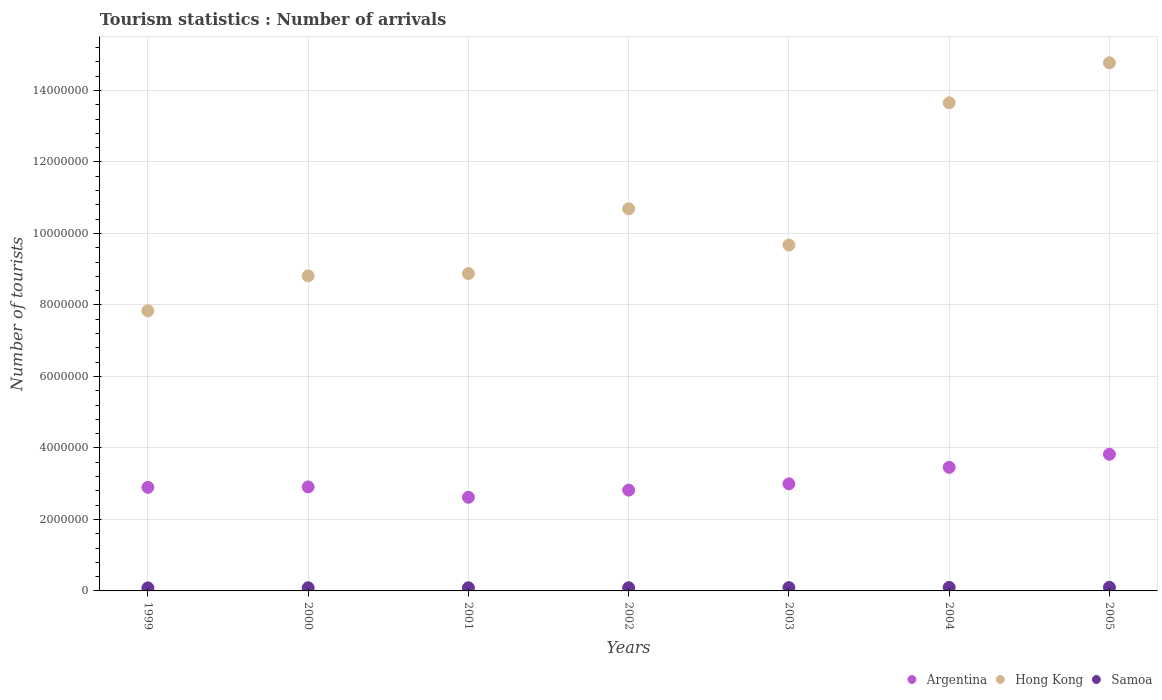How many different coloured dotlines are there?
Make the answer very short. 3. Is the number of dotlines equal to the number of legend labels?
Provide a succinct answer. Yes. What is the number of tourist arrivals in Hong Kong in 2004?
Give a very brief answer. 1.37e+07. Across all years, what is the maximum number of tourist arrivals in Hong Kong?
Offer a very short reply. 1.48e+07. Across all years, what is the minimum number of tourist arrivals in Argentina?
Keep it short and to the point. 2.62e+06. In which year was the number of tourist arrivals in Hong Kong maximum?
Give a very brief answer. 2005. In which year was the number of tourist arrivals in Argentina minimum?
Offer a very short reply. 2001. What is the total number of tourist arrivals in Argentina in the graph?
Give a very brief answer. 2.15e+07. What is the difference between the number of tourist arrivals in Argentina in 2000 and that in 2002?
Ensure brevity in your answer.  8.90e+04. What is the difference between the number of tourist arrivals in Argentina in 2002 and the number of tourist arrivals in Hong Kong in 1999?
Give a very brief answer. -5.02e+06. What is the average number of tourist arrivals in Hong Kong per year?
Your answer should be very brief. 1.06e+07. In the year 2000, what is the difference between the number of tourist arrivals in Hong Kong and number of tourist arrivals in Samoa?
Your answer should be very brief. 8.73e+06. What is the ratio of the number of tourist arrivals in Hong Kong in 2000 to that in 2002?
Make the answer very short. 0.82. Is the number of tourist arrivals in Samoa in 1999 less than that in 2005?
Provide a succinct answer. Yes. What is the difference between the highest and the second highest number of tourist arrivals in Hong Kong?
Provide a succinct answer. 1.12e+06. What is the difference between the highest and the lowest number of tourist arrivals in Hong Kong?
Provide a short and direct response. 6.94e+06. Is the sum of the number of tourist arrivals in Samoa in 2000 and 2002 greater than the maximum number of tourist arrivals in Argentina across all years?
Provide a succinct answer. No. Does the number of tourist arrivals in Hong Kong monotonically increase over the years?
Your answer should be compact. No. Is the number of tourist arrivals in Hong Kong strictly less than the number of tourist arrivals in Argentina over the years?
Your answer should be compact. No. How many dotlines are there?
Provide a short and direct response. 3. How many years are there in the graph?
Give a very brief answer. 7. What is the difference between two consecutive major ticks on the Y-axis?
Offer a terse response. 2.00e+06. What is the title of the graph?
Offer a very short reply. Tourism statistics : Number of arrivals. What is the label or title of the Y-axis?
Your answer should be very brief. Number of tourists. What is the Number of tourists in Argentina in 1999?
Make the answer very short. 2.90e+06. What is the Number of tourists in Hong Kong in 1999?
Provide a short and direct response. 7.84e+06. What is the Number of tourists of Samoa in 1999?
Your answer should be compact. 8.50e+04. What is the Number of tourists in Argentina in 2000?
Offer a terse response. 2.91e+06. What is the Number of tourists of Hong Kong in 2000?
Keep it short and to the point. 8.81e+06. What is the Number of tourists of Samoa in 2000?
Keep it short and to the point. 8.80e+04. What is the Number of tourists in Argentina in 2001?
Keep it short and to the point. 2.62e+06. What is the Number of tourists of Hong Kong in 2001?
Your response must be concise. 8.88e+06. What is the Number of tourists of Samoa in 2001?
Make the answer very short. 8.80e+04. What is the Number of tourists of Argentina in 2002?
Offer a very short reply. 2.82e+06. What is the Number of tourists in Hong Kong in 2002?
Offer a terse response. 1.07e+07. What is the Number of tourists of Samoa in 2002?
Make the answer very short. 8.90e+04. What is the Number of tourists of Argentina in 2003?
Ensure brevity in your answer.  3.00e+06. What is the Number of tourists in Hong Kong in 2003?
Ensure brevity in your answer.  9.68e+06. What is the Number of tourists in Samoa in 2003?
Ensure brevity in your answer.  9.20e+04. What is the Number of tourists of Argentina in 2004?
Offer a terse response. 3.46e+06. What is the Number of tourists of Hong Kong in 2004?
Your answer should be very brief. 1.37e+07. What is the Number of tourists in Samoa in 2004?
Provide a short and direct response. 9.80e+04. What is the Number of tourists of Argentina in 2005?
Your answer should be compact. 3.82e+06. What is the Number of tourists in Hong Kong in 2005?
Ensure brevity in your answer.  1.48e+07. What is the Number of tourists of Samoa in 2005?
Ensure brevity in your answer.  1.02e+05. Across all years, what is the maximum Number of tourists in Argentina?
Provide a short and direct response. 3.82e+06. Across all years, what is the maximum Number of tourists of Hong Kong?
Keep it short and to the point. 1.48e+07. Across all years, what is the maximum Number of tourists of Samoa?
Offer a very short reply. 1.02e+05. Across all years, what is the minimum Number of tourists in Argentina?
Your response must be concise. 2.62e+06. Across all years, what is the minimum Number of tourists of Hong Kong?
Ensure brevity in your answer.  7.84e+06. Across all years, what is the minimum Number of tourists in Samoa?
Offer a terse response. 8.50e+04. What is the total Number of tourists in Argentina in the graph?
Provide a short and direct response. 2.15e+07. What is the total Number of tourists in Hong Kong in the graph?
Your answer should be very brief. 7.43e+07. What is the total Number of tourists of Samoa in the graph?
Offer a terse response. 6.42e+05. What is the difference between the Number of tourists of Argentina in 1999 and that in 2000?
Ensure brevity in your answer.  -1.10e+04. What is the difference between the Number of tourists of Hong Kong in 1999 and that in 2000?
Keep it short and to the point. -9.77e+05. What is the difference between the Number of tourists of Samoa in 1999 and that in 2000?
Offer a terse response. -3000. What is the difference between the Number of tourists of Argentina in 1999 and that in 2001?
Ensure brevity in your answer.  2.78e+05. What is the difference between the Number of tourists of Hong Kong in 1999 and that in 2001?
Give a very brief answer. -1.04e+06. What is the difference between the Number of tourists of Samoa in 1999 and that in 2001?
Ensure brevity in your answer.  -3000. What is the difference between the Number of tourists in Argentina in 1999 and that in 2002?
Make the answer very short. 7.80e+04. What is the difference between the Number of tourists of Hong Kong in 1999 and that in 2002?
Provide a short and direct response. -2.85e+06. What is the difference between the Number of tourists of Samoa in 1999 and that in 2002?
Offer a very short reply. -4000. What is the difference between the Number of tourists of Argentina in 1999 and that in 2003?
Your answer should be compact. -9.70e+04. What is the difference between the Number of tourists of Hong Kong in 1999 and that in 2003?
Your answer should be compact. -1.84e+06. What is the difference between the Number of tourists of Samoa in 1999 and that in 2003?
Make the answer very short. -7000. What is the difference between the Number of tourists of Argentina in 1999 and that in 2004?
Keep it short and to the point. -5.59e+05. What is the difference between the Number of tourists of Hong Kong in 1999 and that in 2004?
Provide a short and direct response. -5.82e+06. What is the difference between the Number of tourists of Samoa in 1999 and that in 2004?
Offer a very short reply. -1.30e+04. What is the difference between the Number of tourists in Argentina in 1999 and that in 2005?
Make the answer very short. -9.25e+05. What is the difference between the Number of tourists of Hong Kong in 1999 and that in 2005?
Keep it short and to the point. -6.94e+06. What is the difference between the Number of tourists of Samoa in 1999 and that in 2005?
Provide a succinct answer. -1.70e+04. What is the difference between the Number of tourists in Argentina in 2000 and that in 2001?
Ensure brevity in your answer.  2.89e+05. What is the difference between the Number of tourists in Hong Kong in 2000 and that in 2001?
Your response must be concise. -6.40e+04. What is the difference between the Number of tourists in Argentina in 2000 and that in 2002?
Your response must be concise. 8.90e+04. What is the difference between the Number of tourists in Hong Kong in 2000 and that in 2002?
Keep it short and to the point. -1.88e+06. What is the difference between the Number of tourists of Samoa in 2000 and that in 2002?
Offer a very short reply. -1000. What is the difference between the Number of tourists of Argentina in 2000 and that in 2003?
Your answer should be compact. -8.60e+04. What is the difference between the Number of tourists in Hong Kong in 2000 and that in 2003?
Provide a short and direct response. -8.62e+05. What is the difference between the Number of tourists of Samoa in 2000 and that in 2003?
Keep it short and to the point. -4000. What is the difference between the Number of tourists of Argentina in 2000 and that in 2004?
Your response must be concise. -5.48e+05. What is the difference between the Number of tourists of Hong Kong in 2000 and that in 2004?
Keep it short and to the point. -4.84e+06. What is the difference between the Number of tourists of Samoa in 2000 and that in 2004?
Offer a terse response. -10000. What is the difference between the Number of tourists of Argentina in 2000 and that in 2005?
Your answer should be compact. -9.14e+05. What is the difference between the Number of tourists in Hong Kong in 2000 and that in 2005?
Give a very brief answer. -5.96e+06. What is the difference between the Number of tourists in Samoa in 2000 and that in 2005?
Give a very brief answer. -1.40e+04. What is the difference between the Number of tourists of Hong Kong in 2001 and that in 2002?
Offer a very short reply. -1.81e+06. What is the difference between the Number of tourists of Samoa in 2001 and that in 2002?
Give a very brief answer. -1000. What is the difference between the Number of tourists in Argentina in 2001 and that in 2003?
Provide a succinct answer. -3.75e+05. What is the difference between the Number of tourists in Hong Kong in 2001 and that in 2003?
Give a very brief answer. -7.98e+05. What is the difference between the Number of tourists in Samoa in 2001 and that in 2003?
Keep it short and to the point. -4000. What is the difference between the Number of tourists in Argentina in 2001 and that in 2004?
Your answer should be compact. -8.37e+05. What is the difference between the Number of tourists in Hong Kong in 2001 and that in 2004?
Provide a short and direct response. -4.78e+06. What is the difference between the Number of tourists in Argentina in 2001 and that in 2005?
Offer a terse response. -1.20e+06. What is the difference between the Number of tourists of Hong Kong in 2001 and that in 2005?
Give a very brief answer. -5.90e+06. What is the difference between the Number of tourists in Samoa in 2001 and that in 2005?
Provide a succinct answer. -1.40e+04. What is the difference between the Number of tourists in Argentina in 2002 and that in 2003?
Your answer should be very brief. -1.75e+05. What is the difference between the Number of tourists in Hong Kong in 2002 and that in 2003?
Your response must be concise. 1.01e+06. What is the difference between the Number of tourists in Samoa in 2002 and that in 2003?
Your response must be concise. -3000. What is the difference between the Number of tourists of Argentina in 2002 and that in 2004?
Provide a succinct answer. -6.37e+05. What is the difference between the Number of tourists of Hong Kong in 2002 and that in 2004?
Offer a terse response. -2.97e+06. What is the difference between the Number of tourists of Samoa in 2002 and that in 2004?
Give a very brief answer. -9000. What is the difference between the Number of tourists of Argentina in 2002 and that in 2005?
Ensure brevity in your answer.  -1.00e+06. What is the difference between the Number of tourists in Hong Kong in 2002 and that in 2005?
Provide a succinct answer. -4.08e+06. What is the difference between the Number of tourists of Samoa in 2002 and that in 2005?
Give a very brief answer. -1.30e+04. What is the difference between the Number of tourists in Argentina in 2003 and that in 2004?
Your answer should be compact. -4.62e+05. What is the difference between the Number of tourists in Hong Kong in 2003 and that in 2004?
Make the answer very short. -3.98e+06. What is the difference between the Number of tourists in Samoa in 2003 and that in 2004?
Offer a terse response. -6000. What is the difference between the Number of tourists in Argentina in 2003 and that in 2005?
Provide a succinct answer. -8.28e+05. What is the difference between the Number of tourists of Hong Kong in 2003 and that in 2005?
Make the answer very short. -5.10e+06. What is the difference between the Number of tourists in Samoa in 2003 and that in 2005?
Offer a terse response. -10000. What is the difference between the Number of tourists in Argentina in 2004 and that in 2005?
Your answer should be compact. -3.66e+05. What is the difference between the Number of tourists of Hong Kong in 2004 and that in 2005?
Offer a terse response. -1.12e+06. What is the difference between the Number of tourists of Samoa in 2004 and that in 2005?
Keep it short and to the point. -4000. What is the difference between the Number of tourists of Argentina in 1999 and the Number of tourists of Hong Kong in 2000?
Offer a terse response. -5.92e+06. What is the difference between the Number of tourists of Argentina in 1999 and the Number of tourists of Samoa in 2000?
Offer a very short reply. 2.81e+06. What is the difference between the Number of tourists in Hong Kong in 1999 and the Number of tourists in Samoa in 2000?
Give a very brief answer. 7.75e+06. What is the difference between the Number of tourists of Argentina in 1999 and the Number of tourists of Hong Kong in 2001?
Provide a succinct answer. -5.98e+06. What is the difference between the Number of tourists in Argentina in 1999 and the Number of tourists in Samoa in 2001?
Your response must be concise. 2.81e+06. What is the difference between the Number of tourists of Hong Kong in 1999 and the Number of tourists of Samoa in 2001?
Provide a short and direct response. 7.75e+06. What is the difference between the Number of tourists in Argentina in 1999 and the Number of tourists in Hong Kong in 2002?
Provide a short and direct response. -7.79e+06. What is the difference between the Number of tourists of Argentina in 1999 and the Number of tourists of Samoa in 2002?
Make the answer very short. 2.81e+06. What is the difference between the Number of tourists in Hong Kong in 1999 and the Number of tourists in Samoa in 2002?
Ensure brevity in your answer.  7.75e+06. What is the difference between the Number of tourists in Argentina in 1999 and the Number of tourists in Hong Kong in 2003?
Ensure brevity in your answer.  -6.78e+06. What is the difference between the Number of tourists of Argentina in 1999 and the Number of tourists of Samoa in 2003?
Your response must be concise. 2.81e+06. What is the difference between the Number of tourists of Hong Kong in 1999 and the Number of tourists of Samoa in 2003?
Your response must be concise. 7.74e+06. What is the difference between the Number of tourists in Argentina in 1999 and the Number of tourists in Hong Kong in 2004?
Offer a very short reply. -1.08e+07. What is the difference between the Number of tourists of Argentina in 1999 and the Number of tourists of Samoa in 2004?
Offer a very short reply. 2.80e+06. What is the difference between the Number of tourists in Hong Kong in 1999 and the Number of tourists in Samoa in 2004?
Offer a very short reply. 7.74e+06. What is the difference between the Number of tourists of Argentina in 1999 and the Number of tourists of Hong Kong in 2005?
Your response must be concise. -1.19e+07. What is the difference between the Number of tourists of Argentina in 1999 and the Number of tourists of Samoa in 2005?
Provide a short and direct response. 2.80e+06. What is the difference between the Number of tourists of Hong Kong in 1999 and the Number of tourists of Samoa in 2005?
Provide a succinct answer. 7.74e+06. What is the difference between the Number of tourists of Argentina in 2000 and the Number of tourists of Hong Kong in 2001?
Your response must be concise. -5.97e+06. What is the difference between the Number of tourists of Argentina in 2000 and the Number of tourists of Samoa in 2001?
Offer a very short reply. 2.82e+06. What is the difference between the Number of tourists of Hong Kong in 2000 and the Number of tourists of Samoa in 2001?
Offer a terse response. 8.73e+06. What is the difference between the Number of tourists of Argentina in 2000 and the Number of tourists of Hong Kong in 2002?
Give a very brief answer. -7.78e+06. What is the difference between the Number of tourists of Argentina in 2000 and the Number of tourists of Samoa in 2002?
Provide a short and direct response. 2.82e+06. What is the difference between the Number of tourists of Hong Kong in 2000 and the Number of tourists of Samoa in 2002?
Keep it short and to the point. 8.72e+06. What is the difference between the Number of tourists in Argentina in 2000 and the Number of tourists in Hong Kong in 2003?
Offer a terse response. -6.77e+06. What is the difference between the Number of tourists of Argentina in 2000 and the Number of tourists of Samoa in 2003?
Give a very brief answer. 2.82e+06. What is the difference between the Number of tourists of Hong Kong in 2000 and the Number of tourists of Samoa in 2003?
Your answer should be very brief. 8.72e+06. What is the difference between the Number of tourists in Argentina in 2000 and the Number of tourists in Hong Kong in 2004?
Offer a terse response. -1.07e+07. What is the difference between the Number of tourists in Argentina in 2000 and the Number of tourists in Samoa in 2004?
Ensure brevity in your answer.  2.81e+06. What is the difference between the Number of tourists of Hong Kong in 2000 and the Number of tourists of Samoa in 2004?
Provide a short and direct response. 8.72e+06. What is the difference between the Number of tourists of Argentina in 2000 and the Number of tourists of Hong Kong in 2005?
Offer a terse response. -1.19e+07. What is the difference between the Number of tourists of Argentina in 2000 and the Number of tourists of Samoa in 2005?
Provide a succinct answer. 2.81e+06. What is the difference between the Number of tourists in Hong Kong in 2000 and the Number of tourists in Samoa in 2005?
Provide a succinct answer. 8.71e+06. What is the difference between the Number of tourists of Argentina in 2001 and the Number of tourists of Hong Kong in 2002?
Provide a short and direct response. -8.07e+06. What is the difference between the Number of tourists in Argentina in 2001 and the Number of tourists in Samoa in 2002?
Keep it short and to the point. 2.53e+06. What is the difference between the Number of tourists in Hong Kong in 2001 and the Number of tourists in Samoa in 2002?
Your answer should be compact. 8.79e+06. What is the difference between the Number of tourists of Argentina in 2001 and the Number of tourists of Hong Kong in 2003?
Your answer should be compact. -7.06e+06. What is the difference between the Number of tourists of Argentina in 2001 and the Number of tourists of Samoa in 2003?
Ensure brevity in your answer.  2.53e+06. What is the difference between the Number of tourists of Hong Kong in 2001 and the Number of tourists of Samoa in 2003?
Your answer should be compact. 8.79e+06. What is the difference between the Number of tourists of Argentina in 2001 and the Number of tourists of Hong Kong in 2004?
Keep it short and to the point. -1.10e+07. What is the difference between the Number of tourists of Argentina in 2001 and the Number of tourists of Samoa in 2004?
Offer a terse response. 2.52e+06. What is the difference between the Number of tourists in Hong Kong in 2001 and the Number of tourists in Samoa in 2004?
Keep it short and to the point. 8.78e+06. What is the difference between the Number of tourists of Argentina in 2001 and the Number of tourists of Hong Kong in 2005?
Ensure brevity in your answer.  -1.22e+07. What is the difference between the Number of tourists of Argentina in 2001 and the Number of tourists of Samoa in 2005?
Make the answer very short. 2.52e+06. What is the difference between the Number of tourists of Hong Kong in 2001 and the Number of tourists of Samoa in 2005?
Ensure brevity in your answer.  8.78e+06. What is the difference between the Number of tourists of Argentina in 2002 and the Number of tourists of Hong Kong in 2003?
Ensure brevity in your answer.  -6.86e+06. What is the difference between the Number of tourists in Argentina in 2002 and the Number of tourists in Samoa in 2003?
Make the answer very short. 2.73e+06. What is the difference between the Number of tourists in Hong Kong in 2002 and the Number of tourists in Samoa in 2003?
Give a very brief answer. 1.06e+07. What is the difference between the Number of tourists of Argentina in 2002 and the Number of tourists of Hong Kong in 2004?
Your answer should be very brief. -1.08e+07. What is the difference between the Number of tourists in Argentina in 2002 and the Number of tourists in Samoa in 2004?
Offer a terse response. 2.72e+06. What is the difference between the Number of tourists of Hong Kong in 2002 and the Number of tourists of Samoa in 2004?
Provide a succinct answer. 1.06e+07. What is the difference between the Number of tourists of Argentina in 2002 and the Number of tourists of Hong Kong in 2005?
Offer a terse response. -1.20e+07. What is the difference between the Number of tourists of Argentina in 2002 and the Number of tourists of Samoa in 2005?
Provide a short and direct response. 2.72e+06. What is the difference between the Number of tourists in Hong Kong in 2002 and the Number of tourists in Samoa in 2005?
Make the answer very short. 1.06e+07. What is the difference between the Number of tourists of Argentina in 2003 and the Number of tourists of Hong Kong in 2004?
Provide a succinct answer. -1.07e+07. What is the difference between the Number of tourists in Argentina in 2003 and the Number of tourists in Samoa in 2004?
Your response must be concise. 2.90e+06. What is the difference between the Number of tourists of Hong Kong in 2003 and the Number of tourists of Samoa in 2004?
Keep it short and to the point. 9.58e+06. What is the difference between the Number of tourists of Argentina in 2003 and the Number of tourists of Hong Kong in 2005?
Ensure brevity in your answer.  -1.18e+07. What is the difference between the Number of tourists in Argentina in 2003 and the Number of tourists in Samoa in 2005?
Offer a terse response. 2.89e+06. What is the difference between the Number of tourists in Hong Kong in 2003 and the Number of tourists in Samoa in 2005?
Keep it short and to the point. 9.57e+06. What is the difference between the Number of tourists of Argentina in 2004 and the Number of tourists of Hong Kong in 2005?
Keep it short and to the point. -1.13e+07. What is the difference between the Number of tourists in Argentina in 2004 and the Number of tourists in Samoa in 2005?
Offer a terse response. 3.36e+06. What is the difference between the Number of tourists in Hong Kong in 2004 and the Number of tourists in Samoa in 2005?
Give a very brief answer. 1.36e+07. What is the average Number of tourists of Argentina per year?
Ensure brevity in your answer.  3.07e+06. What is the average Number of tourists of Hong Kong per year?
Make the answer very short. 1.06e+07. What is the average Number of tourists of Samoa per year?
Give a very brief answer. 9.17e+04. In the year 1999, what is the difference between the Number of tourists in Argentina and Number of tourists in Hong Kong?
Provide a short and direct response. -4.94e+06. In the year 1999, what is the difference between the Number of tourists in Argentina and Number of tourists in Samoa?
Provide a short and direct response. 2.81e+06. In the year 1999, what is the difference between the Number of tourists in Hong Kong and Number of tourists in Samoa?
Keep it short and to the point. 7.75e+06. In the year 2000, what is the difference between the Number of tourists in Argentina and Number of tourists in Hong Kong?
Make the answer very short. -5.90e+06. In the year 2000, what is the difference between the Number of tourists of Argentina and Number of tourists of Samoa?
Give a very brief answer. 2.82e+06. In the year 2000, what is the difference between the Number of tourists of Hong Kong and Number of tourists of Samoa?
Keep it short and to the point. 8.73e+06. In the year 2001, what is the difference between the Number of tourists in Argentina and Number of tourists in Hong Kong?
Your answer should be compact. -6.26e+06. In the year 2001, what is the difference between the Number of tourists in Argentina and Number of tourists in Samoa?
Offer a very short reply. 2.53e+06. In the year 2001, what is the difference between the Number of tourists in Hong Kong and Number of tourists in Samoa?
Your answer should be very brief. 8.79e+06. In the year 2002, what is the difference between the Number of tourists in Argentina and Number of tourists in Hong Kong?
Make the answer very short. -7.87e+06. In the year 2002, what is the difference between the Number of tourists in Argentina and Number of tourists in Samoa?
Offer a very short reply. 2.73e+06. In the year 2002, what is the difference between the Number of tourists of Hong Kong and Number of tourists of Samoa?
Offer a terse response. 1.06e+07. In the year 2003, what is the difference between the Number of tourists in Argentina and Number of tourists in Hong Kong?
Provide a succinct answer. -6.68e+06. In the year 2003, what is the difference between the Number of tourists in Argentina and Number of tourists in Samoa?
Make the answer very short. 2.90e+06. In the year 2003, what is the difference between the Number of tourists of Hong Kong and Number of tourists of Samoa?
Your response must be concise. 9.58e+06. In the year 2004, what is the difference between the Number of tourists of Argentina and Number of tourists of Hong Kong?
Your answer should be compact. -1.02e+07. In the year 2004, what is the difference between the Number of tourists of Argentina and Number of tourists of Samoa?
Ensure brevity in your answer.  3.36e+06. In the year 2004, what is the difference between the Number of tourists of Hong Kong and Number of tourists of Samoa?
Your response must be concise. 1.36e+07. In the year 2005, what is the difference between the Number of tourists in Argentina and Number of tourists in Hong Kong?
Give a very brief answer. -1.10e+07. In the year 2005, what is the difference between the Number of tourists of Argentina and Number of tourists of Samoa?
Offer a very short reply. 3.72e+06. In the year 2005, what is the difference between the Number of tourists in Hong Kong and Number of tourists in Samoa?
Provide a succinct answer. 1.47e+07. What is the ratio of the Number of tourists in Argentina in 1999 to that in 2000?
Ensure brevity in your answer.  1. What is the ratio of the Number of tourists of Hong Kong in 1999 to that in 2000?
Offer a very short reply. 0.89. What is the ratio of the Number of tourists of Samoa in 1999 to that in 2000?
Ensure brevity in your answer.  0.97. What is the ratio of the Number of tourists of Argentina in 1999 to that in 2001?
Your answer should be compact. 1.11. What is the ratio of the Number of tourists in Hong Kong in 1999 to that in 2001?
Ensure brevity in your answer.  0.88. What is the ratio of the Number of tourists in Samoa in 1999 to that in 2001?
Make the answer very short. 0.97. What is the ratio of the Number of tourists of Argentina in 1999 to that in 2002?
Offer a very short reply. 1.03. What is the ratio of the Number of tourists in Hong Kong in 1999 to that in 2002?
Your answer should be very brief. 0.73. What is the ratio of the Number of tourists of Samoa in 1999 to that in 2002?
Ensure brevity in your answer.  0.96. What is the ratio of the Number of tourists of Argentina in 1999 to that in 2003?
Ensure brevity in your answer.  0.97. What is the ratio of the Number of tourists in Hong Kong in 1999 to that in 2003?
Provide a succinct answer. 0.81. What is the ratio of the Number of tourists of Samoa in 1999 to that in 2003?
Keep it short and to the point. 0.92. What is the ratio of the Number of tourists of Argentina in 1999 to that in 2004?
Give a very brief answer. 0.84. What is the ratio of the Number of tourists in Hong Kong in 1999 to that in 2004?
Keep it short and to the point. 0.57. What is the ratio of the Number of tourists of Samoa in 1999 to that in 2004?
Keep it short and to the point. 0.87. What is the ratio of the Number of tourists of Argentina in 1999 to that in 2005?
Keep it short and to the point. 0.76. What is the ratio of the Number of tourists in Hong Kong in 1999 to that in 2005?
Make the answer very short. 0.53. What is the ratio of the Number of tourists in Samoa in 1999 to that in 2005?
Make the answer very short. 0.83. What is the ratio of the Number of tourists of Argentina in 2000 to that in 2001?
Your response must be concise. 1.11. What is the ratio of the Number of tourists in Samoa in 2000 to that in 2001?
Make the answer very short. 1. What is the ratio of the Number of tourists in Argentina in 2000 to that in 2002?
Your response must be concise. 1.03. What is the ratio of the Number of tourists of Hong Kong in 2000 to that in 2002?
Provide a succinct answer. 0.82. What is the ratio of the Number of tourists in Samoa in 2000 to that in 2002?
Provide a succinct answer. 0.99. What is the ratio of the Number of tourists of Argentina in 2000 to that in 2003?
Ensure brevity in your answer.  0.97. What is the ratio of the Number of tourists of Hong Kong in 2000 to that in 2003?
Provide a succinct answer. 0.91. What is the ratio of the Number of tourists of Samoa in 2000 to that in 2003?
Your response must be concise. 0.96. What is the ratio of the Number of tourists in Argentina in 2000 to that in 2004?
Ensure brevity in your answer.  0.84. What is the ratio of the Number of tourists of Hong Kong in 2000 to that in 2004?
Your response must be concise. 0.65. What is the ratio of the Number of tourists in Samoa in 2000 to that in 2004?
Keep it short and to the point. 0.9. What is the ratio of the Number of tourists of Argentina in 2000 to that in 2005?
Your response must be concise. 0.76. What is the ratio of the Number of tourists in Hong Kong in 2000 to that in 2005?
Give a very brief answer. 0.6. What is the ratio of the Number of tourists of Samoa in 2000 to that in 2005?
Ensure brevity in your answer.  0.86. What is the ratio of the Number of tourists of Argentina in 2001 to that in 2002?
Give a very brief answer. 0.93. What is the ratio of the Number of tourists in Hong Kong in 2001 to that in 2002?
Make the answer very short. 0.83. What is the ratio of the Number of tourists of Samoa in 2001 to that in 2002?
Ensure brevity in your answer.  0.99. What is the ratio of the Number of tourists of Argentina in 2001 to that in 2003?
Ensure brevity in your answer.  0.87. What is the ratio of the Number of tourists in Hong Kong in 2001 to that in 2003?
Provide a short and direct response. 0.92. What is the ratio of the Number of tourists of Samoa in 2001 to that in 2003?
Provide a short and direct response. 0.96. What is the ratio of the Number of tourists of Argentina in 2001 to that in 2004?
Provide a short and direct response. 0.76. What is the ratio of the Number of tourists of Hong Kong in 2001 to that in 2004?
Provide a short and direct response. 0.65. What is the ratio of the Number of tourists in Samoa in 2001 to that in 2004?
Offer a very short reply. 0.9. What is the ratio of the Number of tourists in Argentina in 2001 to that in 2005?
Your answer should be compact. 0.69. What is the ratio of the Number of tourists in Hong Kong in 2001 to that in 2005?
Offer a terse response. 0.6. What is the ratio of the Number of tourists in Samoa in 2001 to that in 2005?
Offer a very short reply. 0.86. What is the ratio of the Number of tourists in Argentina in 2002 to that in 2003?
Provide a short and direct response. 0.94. What is the ratio of the Number of tourists in Hong Kong in 2002 to that in 2003?
Make the answer very short. 1.1. What is the ratio of the Number of tourists of Samoa in 2002 to that in 2003?
Your response must be concise. 0.97. What is the ratio of the Number of tourists of Argentina in 2002 to that in 2004?
Offer a terse response. 0.82. What is the ratio of the Number of tourists in Hong Kong in 2002 to that in 2004?
Keep it short and to the point. 0.78. What is the ratio of the Number of tourists in Samoa in 2002 to that in 2004?
Ensure brevity in your answer.  0.91. What is the ratio of the Number of tourists of Argentina in 2002 to that in 2005?
Ensure brevity in your answer.  0.74. What is the ratio of the Number of tourists in Hong Kong in 2002 to that in 2005?
Ensure brevity in your answer.  0.72. What is the ratio of the Number of tourists of Samoa in 2002 to that in 2005?
Keep it short and to the point. 0.87. What is the ratio of the Number of tourists of Argentina in 2003 to that in 2004?
Make the answer very short. 0.87. What is the ratio of the Number of tourists in Hong Kong in 2003 to that in 2004?
Keep it short and to the point. 0.71. What is the ratio of the Number of tourists in Samoa in 2003 to that in 2004?
Provide a short and direct response. 0.94. What is the ratio of the Number of tourists in Argentina in 2003 to that in 2005?
Your response must be concise. 0.78. What is the ratio of the Number of tourists in Hong Kong in 2003 to that in 2005?
Give a very brief answer. 0.66. What is the ratio of the Number of tourists of Samoa in 2003 to that in 2005?
Offer a very short reply. 0.9. What is the ratio of the Number of tourists in Argentina in 2004 to that in 2005?
Keep it short and to the point. 0.9. What is the ratio of the Number of tourists in Hong Kong in 2004 to that in 2005?
Give a very brief answer. 0.92. What is the ratio of the Number of tourists in Samoa in 2004 to that in 2005?
Offer a terse response. 0.96. What is the difference between the highest and the second highest Number of tourists of Argentina?
Your answer should be compact. 3.66e+05. What is the difference between the highest and the second highest Number of tourists in Hong Kong?
Ensure brevity in your answer.  1.12e+06. What is the difference between the highest and the second highest Number of tourists of Samoa?
Ensure brevity in your answer.  4000. What is the difference between the highest and the lowest Number of tourists in Argentina?
Make the answer very short. 1.20e+06. What is the difference between the highest and the lowest Number of tourists of Hong Kong?
Your answer should be very brief. 6.94e+06. What is the difference between the highest and the lowest Number of tourists of Samoa?
Keep it short and to the point. 1.70e+04. 